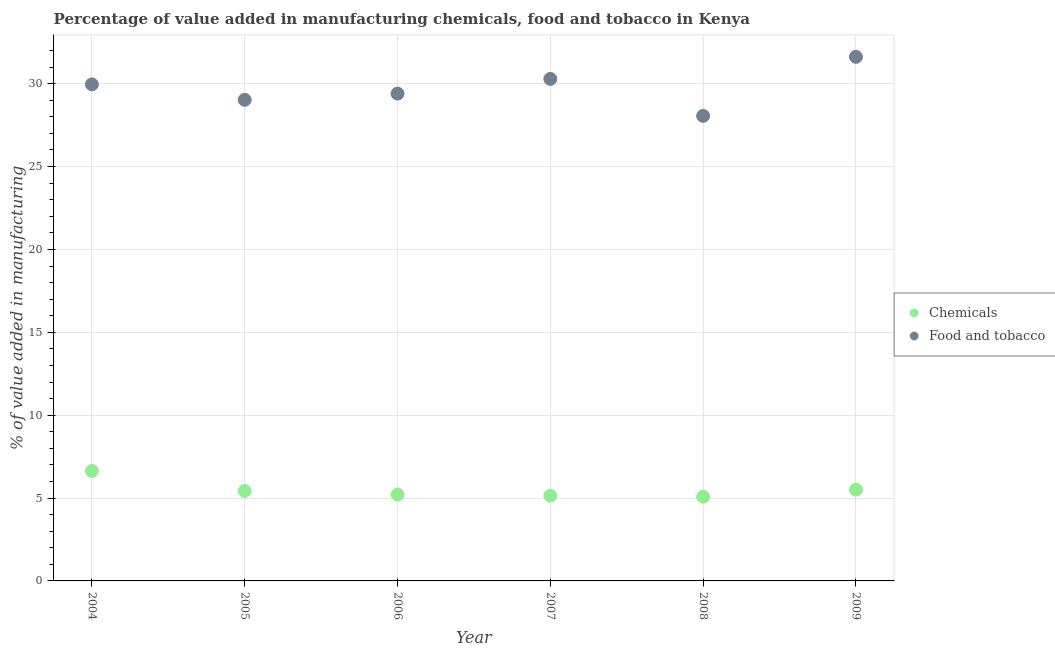How many different coloured dotlines are there?
Keep it short and to the point. 2. Is the number of dotlines equal to the number of legend labels?
Offer a terse response. Yes. What is the value added by manufacturing food and tobacco in 2008?
Offer a very short reply. 28.06. Across all years, what is the maximum value added by manufacturing food and tobacco?
Offer a terse response. 31.62. Across all years, what is the minimum value added by  manufacturing chemicals?
Provide a short and direct response. 5.08. In which year was the value added by manufacturing food and tobacco maximum?
Make the answer very short. 2009. In which year was the value added by manufacturing food and tobacco minimum?
Offer a very short reply. 2008. What is the total value added by  manufacturing chemicals in the graph?
Ensure brevity in your answer.  33.01. What is the difference between the value added by manufacturing food and tobacco in 2005 and that in 2008?
Your response must be concise. 0.97. What is the difference between the value added by  manufacturing chemicals in 2007 and the value added by manufacturing food and tobacco in 2004?
Your answer should be very brief. -24.82. What is the average value added by  manufacturing chemicals per year?
Offer a terse response. 5.5. In the year 2005, what is the difference between the value added by manufacturing food and tobacco and value added by  manufacturing chemicals?
Your answer should be compact. 23.6. In how many years, is the value added by manufacturing food and tobacco greater than 3 %?
Keep it short and to the point. 6. What is the ratio of the value added by manufacturing food and tobacco in 2004 to that in 2007?
Make the answer very short. 0.99. Is the difference between the value added by  manufacturing chemicals in 2004 and 2007 greater than the difference between the value added by manufacturing food and tobacco in 2004 and 2007?
Offer a very short reply. Yes. What is the difference between the highest and the second highest value added by manufacturing food and tobacco?
Provide a short and direct response. 1.33. What is the difference between the highest and the lowest value added by manufacturing food and tobacco?
Give a very brief answer. 3.56. In how many years, is the value added by manufacturing food and tobacco greater than the average value added by manufacturing food and tobacco taken over all years?
Give a very brief answer. 3. How many dotlines are there?
Give a very brief answer. 2. How many years are there in the graph?
Offer a terse response. 6. Are the values on the major ticks of Y-axis written in scientific E-notation?
Make the answer very short. No. Does the graph contain grids?
Give a very brief answer. Yes. Where does the legend appear in the graph?
Ensure brevity in your answer.  Center right. How are the legend labels stacked?
Provide a succinct answer. Vertical. What is the title of the graph?
Offer a terse response. Percentage of value added in manufacturing chemicals, food and tobacco in Kenya. What is the label or title of the X-axis?
Your answer should be compact. Year. What is the label or title of the Y-axis?
Your response must be concise. % of value added in manufacturing. What is the % of value added in manufacturing in Chemicals in 2004?
Offer a terse response. 6.64. What is the % of value added in manufacturing in Food and tobacco in 2004?
Ensure brevity in your answer.  29.96. What is the % of value added in manufacturing of Chemicals in 2005?
Provide a short and direct response. 5.43. What is the % of value added in manufacturing in Food and tobacco in 2005?
Ensure brevity in your answer.  29.03. What is the % of value added in manufacturing in Chemicals in 2006?
Ensure brevity in your answer.  5.22. What is the % of value added in manufacturing of Food and tobacco in 2006?
Offer a terse response. 29.4. What is the % of value added in manufacturing of Chemicals in 2007?
Your response must be concise. 5.14. What is the % of value added in manufacturing in Food and tobacco in 2007?
Make the answer very short. 30.29. What is the % of value added in manufacturing in Chemicals in 2008?
Your answer should be very brief. 5.08. What is the % of value added in manufacturing in Food and tobacco in 2008?
Provide a short and direct response. 28.06. What is the % of value added in manufacturing in Chemicals in 2009?
Offer a terse response. 5.51. What is the % of value added in manufacturing in Food and tobacco in 2009?
Provide a succinct answer. 31.62. Across all years, what is the maximum % of value added in manufacturing of Chemicals?
Give a very brief answer. 6.64. Across all years, what is the maximum % of value added in manufacturing of Food and tobacco?
Your answer should be very brief. 31.62. Across all years, what is the minimum % of value added in manufacturing in Chemicals?
Keep it short and to the point. 5.08. Across all years, what is the minimum % of value added in manufacturing in Food and tobacco?
Make the answer very short. 28.06. What is the total % of value added in manufacturing of Chemicals in the graph?
Your answer should be very brief. 33.01. What is the total % of value added in manufacturing in Food and tobacco in the graph?
Ensure brevity in your answer.  178.35. What is the difference between the % of value added in manufacturing of Chemicals in 2004 and that in 2005?
Offer a very short reply. 1.21. What is the difference between the % of value added in manufacturing of Food and tobacco in 2004 and that in 2005?
Ensure brevity in your answer.  0.93. What is the difference between the % of value added in manufacturing in Chemicals in 2004 and that in 2006?
Make the answer very short. 1.42. What is the difference between the % of value added in manufacturing in Food and tobacco in 2004 and that in 2006?
Your response must be concise. 0.56. What is the difference between the % of value added in manufacturing in Chemicals in 2004 and that in 2007?
Your answer should be compact. 1.5. What is the difference between the % of value added in manufacturing in Food and tobacco in 2004 and that in 2007?
Provide a short and direct response. -0.33. What is the difference between the % of value added in manufacturing in Chemicals in 2004 and that in 2008?
Provide a short and direct response. 1.56. What is the difference between the % of value added in manufacturing in Food and tobacco in 2004 and that in 2008?
Your answer should be very brief. 1.9. What is the difference between the % of value added in manufacturing of Chemicals in 2004 and that in 2009?
Your response must be concise. 1.13. What is the difference between the % of value added in manufacturing in Food and tobacco in 2004 and that in 2009?
Your answer should be very brief. -1.66. What is the difference between the % of value added in manufacturing of Chemicals in 2005 and that in 2006?
Keep it short and to the point. 0.21. What is the difference between the % of value added in manufacturing in Food and tobacco in 2005 and that in 2006?
Provide a short and direct response. -0.38. What is the difference between the % of value added in manufacturing of Chemicals in 2005 and that in 2007?
Your answer should be very brief. 0.29. What is the difference between the % of value added in manufacturing in Food and tobacco in 2005 and that in 2007?
Your response must be concise. -1.26. What is the difference between the % of value added in manufacturing in Chemicals in 2005 and that in 2008?
Provide a succinct answer. 0.35. What is the difference between the % of value added in manufacturing in Food and tobacco in 2005 and that in 2008?
Your answer should be compact. 0.97. What is the difference between the % of value added in manufacturing of Chemicals in 2005 and that in 2009?
Make the answer very short. -0.08. What is the difference between the % of value added in manufacturing in Food and tobacco in 2005 and that in 2009?
Provide a succinct answer. -2.59. What is the difference between the % of value added in manufacturing in Chemicals in 2006 and that in 2007?
Your response must be concise. 0.08. What is the difference between the % of value added in manufacturing in Food and tobacco in 2006 and that in 2007?
Ensure brevity in your answer.  -0.89. What is the difference between the % of value added in manufacturing in Chemicals in 2006 and that in 2008?
Ensure brevity in your answer.  0.14. What is the difference between the % of value added in manufacturing of Food and tobacco in 2006 and that in 2008?
Provide a short and direct response. 1.34. What is the difference between the % of value added in manufacturing of Chemicals in 2006 and that in 2009?
Your answer should be compact. -0.29. What is the difference between the % of value added in manufacturing in Food and tobacco in 2006 and that in 2009?
Your answer should be compact. -2.22. What is the difference between the % of value added in manufacturing in Chemicals in 2007 and that in 2008?
Your answer should be compact. 0.06. What is the difference between the % of value added in manufacturing of Food and tobacco in 2007 and that in 2008?
Ensure brevity in your answer.  2.23. What is the difference between the % of value added in manufacturing in Chemicals in 2007 and that in 2009?
Provide a succinct answer. -0.37. What is the difference between the % of value added in manufacturing of Food and tobacco in 2007 and that in 2009?
Your answer should be very brief. -1.33. What is the difference between the % of value added in manufacturing of Chemicals in 2008 and that in 2009?
Provide a short and direct response. -0.42. What is the difference between the % of value added in manufacturing of Food and tobacco in 2008 and that in 2009?
Your response must be concise. -3.56. What is the difference between the % of value added in manufacturing of Chemicals in 2004 and the % of value added in manufacturing of Food and tobacco in 2005?
Offer a very short reply. -22.39. What is the difference between the % of value added in manufacturing of Chemicals in 2004 and the % of value added in manufacturing of Food and tobacco in 2006?
Make the answer very short. -22.77. What is the difference between the % of value added in manufacturing of Chemicals in 2004 and the % of value added in manufacturing of Food and tobacco in 2007?
Give a very brief answer. -23.65. What is the difference between the % of value added in manufacturing in Chemicals in 2004 and the % of value added in manufacturing in Food and tobacco in 2008?
Provide a short and direct response. -21.42. What is the difference between the % of value added in manufacturing of Chemicals in 2004 and the % of value added in manufacturing of Food and tobacco in 2009?
Your answer should be very brief. -24.98. What is the difference between the % of value added in manufacturing in Chemicals in 2005 and the % of value added in manufacturing in Food and tobacco in 2006?
Make the answer very short. -23.97. What is the difference between the % of value added in manufacturing of Chemicals in 2005 and the % of value added in manufacturing of Food and tobacco in 2007?
Offer a terse response. -24.86. What is the difference between the % of value added in manufacturing of Chemicals in 2005 and the % of value added in manufacturing of Food and tobacco in 2008?
Offer a terse response. -22.63. What is the difference between the % of value added in manufacturing in Chemicals in 2005 and the % of value added in manufacturing in Food and tobacco in 2009?
Provide a short and direct response. -26.19. What is the difference between the % of value added in manufacturing of Chemicals in 2006 and the % of value added in manufacturing of Food and tobacco in 2007?
Provide a succinct answer. -25.07. What is the difference between the % of value added in manufacturing in Chemicals in 2006 and the % of value added in manufacturing in Food and tobacco in 2008?
Provide a short and direct response. -22.84. What is the difference between the % of value added in manufacturing in Chemicals in 2006 and the % of value added in manufacturing in Food and tobacco in 2009?
Provide a short and direct response. -26.4. What is the difference between the % of value added in manufacturing in Chemicals in 2007 and the % of value added in manufacturing in Food and tobacco in 2008?
Keep it short and to the point. -22.92. What is the difference between the % of value added in manufacturing of Chemicals in 2007 and the % of value added in manufacturing of Food and tobacco in 2009?
Provide a succinct answer. -26.48. What is the difference between the % of value added in manufacturing in Chemicals in 2008 and the % of value added in manufacturing in Food and tobacco in 2009?
Make the answer very short. -26.54. What is the average % of value added in manufacturing in Chemicals per year?
Your response must be concise. 5.5. What is the average % of value added in manufacturing of Food and tobacco per year?
Give a very brief answer. 29.73. In the year 2004, what is the difference between the % of value added in manufacturing in Chemicals and % of value added in manufacturing in Food and tobacco?
Ensure brevity in your answer.  -23.32. In the year 2005, what is the difference between the % of value added in manufacturing of Chemicals and % of value added in manufacturing of Food and tobacco?
Your answer should be compact. -23.6. In the year 2006, what is the difference between the % of value added in manufacturing in Chemicals and % of value added in manufacturing in Food and tobacco?
Ensure brevity in your answer.  -24.19. In the year 2007, what is the difference between the % of value added in manufacturing in Chemicals and % of value added in manufacturing in Food and tobacco?
Give a very brief answer. -25.15. In the year 2008, what is the difference between the % of value added in manufacturing in Chemicals and % of value added in manufacturing in Food and tobacco?
Ensure brevity in your answer.  -22.98. In the year 2009, what is the difference between the % of value added in manufacturing in Chemicals and % of value added in manufacturing in Food and tobacco?
Make the answer very short. -26.11. What is the ratio of the % of value added in manufacturing in Chemicals in 2004 to that in 2005?
Your answer should be compact. 1.22. What is the ratio of the % of value added in manufacturing of Food and tobacco in 2004 to that in 2005?
Your answer should be compact. 1.03. What is the ratio of the % of value added in manufacturing in Chemicals in 2004 to that in 2006?
Keep it short and to the point. 1.27. What is the ratio of the % of value added in manufacturing in Food and tobacco in 2004 to that in 2006?
Keep it short and to the point. 1.02. What is the ratio of the % of value added in manufacturing in Chemicals in 2004 to that in 2007?
Provide a short and direct response. 1.29. What is the ratio of the % of value added in manufacturing in Food and tobacco in 2004 to that in 2007?
Ensure brevity in your answer.  0.99. What is the ratio of the % of value added in manufacturing in Chemicals in 2004 to that in 2008?
Your answer should be compact. 1.31. What is the ratio of the % of value added in manufacturing of Food and tobacco in 2004 to that in 2008?
Your answer should be very brief. 1.07. What is the ratio of the % of value added in manufacturing in Chemicals in 2004 to that in 2009?
Provide a succinct answer. 1.21. What is the ratio of the % of value added in manufacturing in Food and tobacco in 2004 to that in 2009?
Make the answer very short. 0.95. What is the ratio of the % of value added in manufacturing of Chemicals in 2005 to that in 2006?
Provide a short and direct response. 1.04. What is the ratio of the % of value added in manufacturing in Food and tobacco in 2005 to that in 2006?
Provide a short and direct response. 0.99. What is the ratio of the % of value added in manufacturing in Chemicals in 2005 to that in 2007?
Your response must be concise. 1.06. What is the ratio of the % of value added in manufacturing of Food and tobacco in 2005 to that in 2007?
Keep it short and to the point. 0.96. What is the ratio of the % of value added in manufacturing of Chemicals in 2005 to that in 2008?
Give a very brief answer. 1.07. What is the ratio of the % of value added in manufacturing in Food and tobacco in 2005 to that in 2008?
Provide a short and direct response. 1.03. What is the ratio of the % of value added in manufacturing of Chemicals in 2005 to that in 2009?
Your answer should be very brief. 0.99. What is the ratio of the % of value added in manufacturing in Food and tobacco in 2005 to that in 2009?
Provide a succinct answer. 0.92. What is the ratio of the % of value added in manufacturing in Chemicals in 2006 to that in 2007?
Offer a terse response. 1.02. What is the ratio of the % of value added in manufacturing in Food and tobacco in 2006 to that in 2007?
Your answer should be very brief. 0.97. What is the ratio of the % of value added in manufacturing in Chemicals in 2006 to that in 2008?
Ensure brevity in your answer.  1.03. What is the ratio of the % of value added in manufacturing of Food and tobacco in 2006 to that in 2008?
Your response must be concise. 1.05. What is the ratio of the % of value added in manufacturing of Chemicals in 2006 to that in 2009?
Provide a succinct answer. 0.95. What is the ratio of the % of value added in manufacturing in Food and tobacco in 2006 to that in 2009?
Give a very brief answer. 0.93. What is the ratio of the % of value added in manufacturing in Chemicals in 2007 to that in 2008?
Provide a succinct answer. 1.01. What is the ratio of the % of value added in manufacturing of Food and tobacco in 2007 to that in 2008?
Ensure brevity in your answer.  1.08. What is the ratio of the % of value added in manufacturing in Chemicals in 2007 to that in 2009?
Your answer should be compact. 0.93. What is the ratio of the % of value added in manufacturing of Food and tobacco in 2007 to that in 2009?
Make the answer very short. 0.96. What is the ratio of the % of value added in manufacturing in Chemicals in 2008 to that in 2009?
Your answer should be very brief. 0.92. What is the ratio of the % of value added in manufacturing in Food and tobacco in 2008 to that in 2009?
Provide a short and direct response. 0.89. What is the difference between the highest and the second highest % of value added in manufacturing of Chemicals?
Give a very brief answer. 1.13. What is the difference between the highest and the second highest % of value added in manufacturing of Food and tobacco?
Your response must be concise. 1.33. What is the difference between the highest and the lowest % of value added in manufacturing of Chemicals?
Keep it short and to the point. 1.56. What is the difference between the highest and the lowest % of value added in manufacturing of Food and tobacco?
Provide a succinct answer. 3.56. 